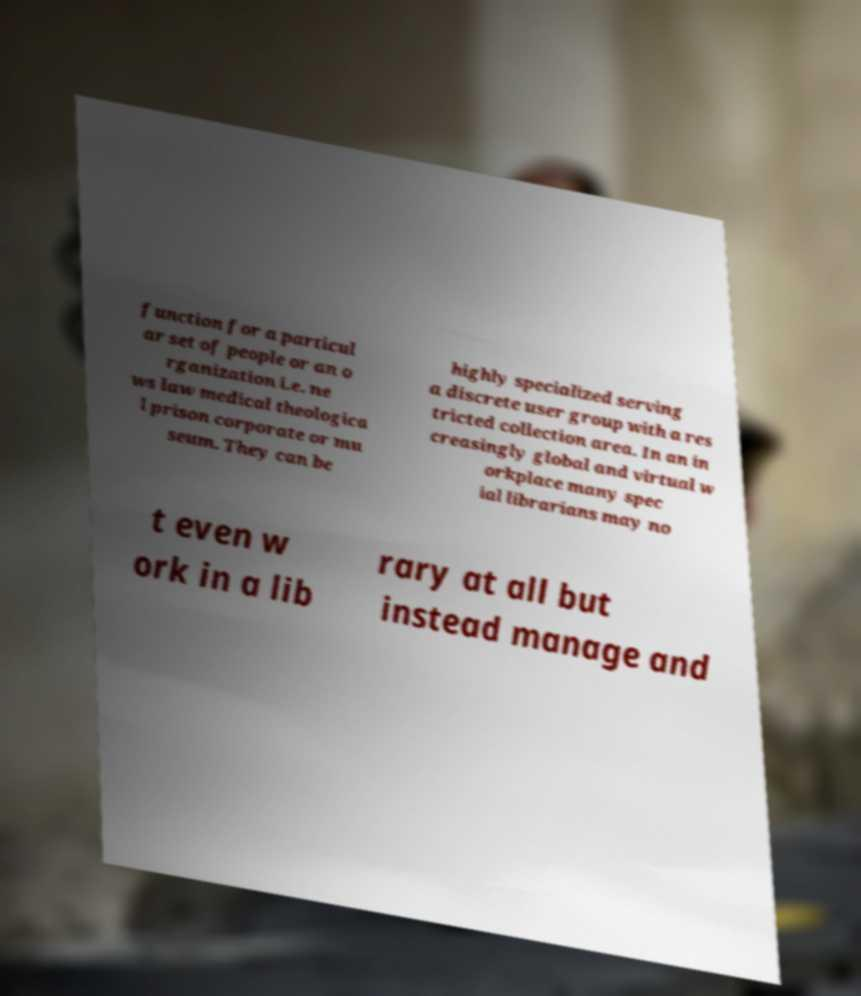Could you assist in decoding the text presented in this image and type it out clearly? function for a particul ar set of people or an o rganization i.e. ne ws law medical theologica l prison corporate or mu seum. They can be highly specialized serving a discrete user group with a res tricted collection area. In an in creasingly global and virtual w orkplace many spec ial librarians may no t even w ork in a lib rary at all but instead manage and 